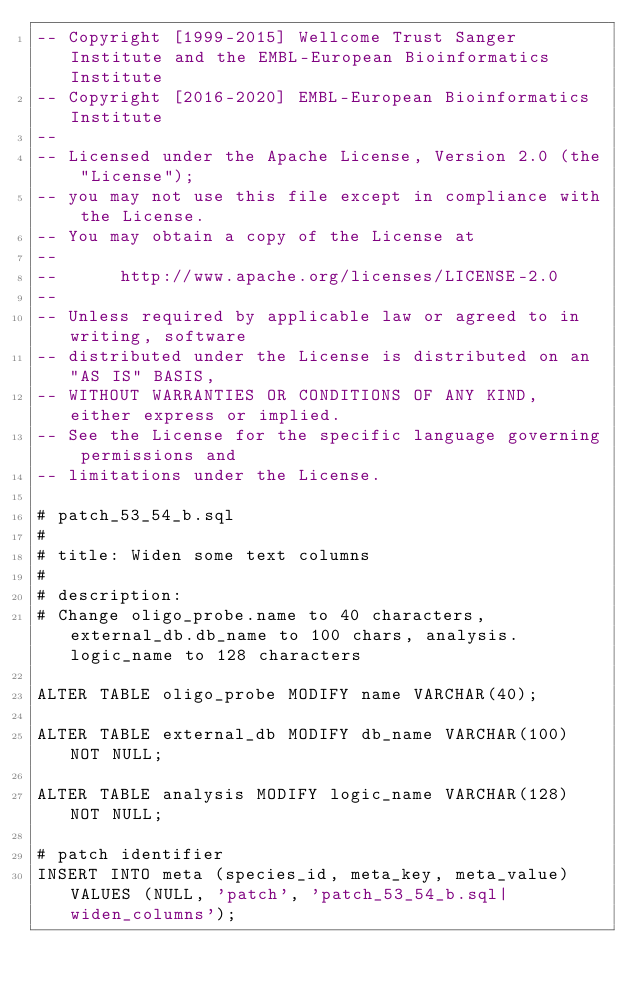<code> <loc_0><loc_0><loc_500><loc_500><_SQL_>-- Copyright [1999-2015] Wellcome Trust Sanger Institute and the EMBL-European Bioinformatics Institute
-- Copyright [2016-2020] EMBL-European Bioinformatics Institute
-- 
-- Licensed under the Apache License, Version 2.0 (the "License");
-- you may not use this file except in compliance with the License.
-- You may obtain a copy of the License at
-- 
--      http://www.apache.org/licenses/LICENSE-2.0
-- 
-- Unless required by applicable law or agreed to in writing, software
-- distributed under the License is distributed on an "AS IS" BASIS,
-- WITHOUT WARRANTIES OR CONDITIONS OF ANY KIND, either express or implied.
-- See the License for the specific language governing permissions and
-- limitations under the License.

# patch_53_54_b.sql
#
# title: Widen some text columns
#
# description:
# Change oligo_probe.name to 40 characters, external_db.db_name to 100 chars, analysis.logic_name to 128 characters

ALTER TABLE oligo_probe MODIFY name VARCHAR(40);

ALTER TABLE external_db MODIFY db_name VARCHAR(100) NOT NULL;

ALTER TABLE analysis MODIFY logic_name VARCHAR(128) NOT NULL;

# patch identifier
INSERT INTO meta (species_id, meta_key, meta_value) VALUES (NULL, 'patch', 'patch_53_54_b.sql|widen_columns');


</code> 